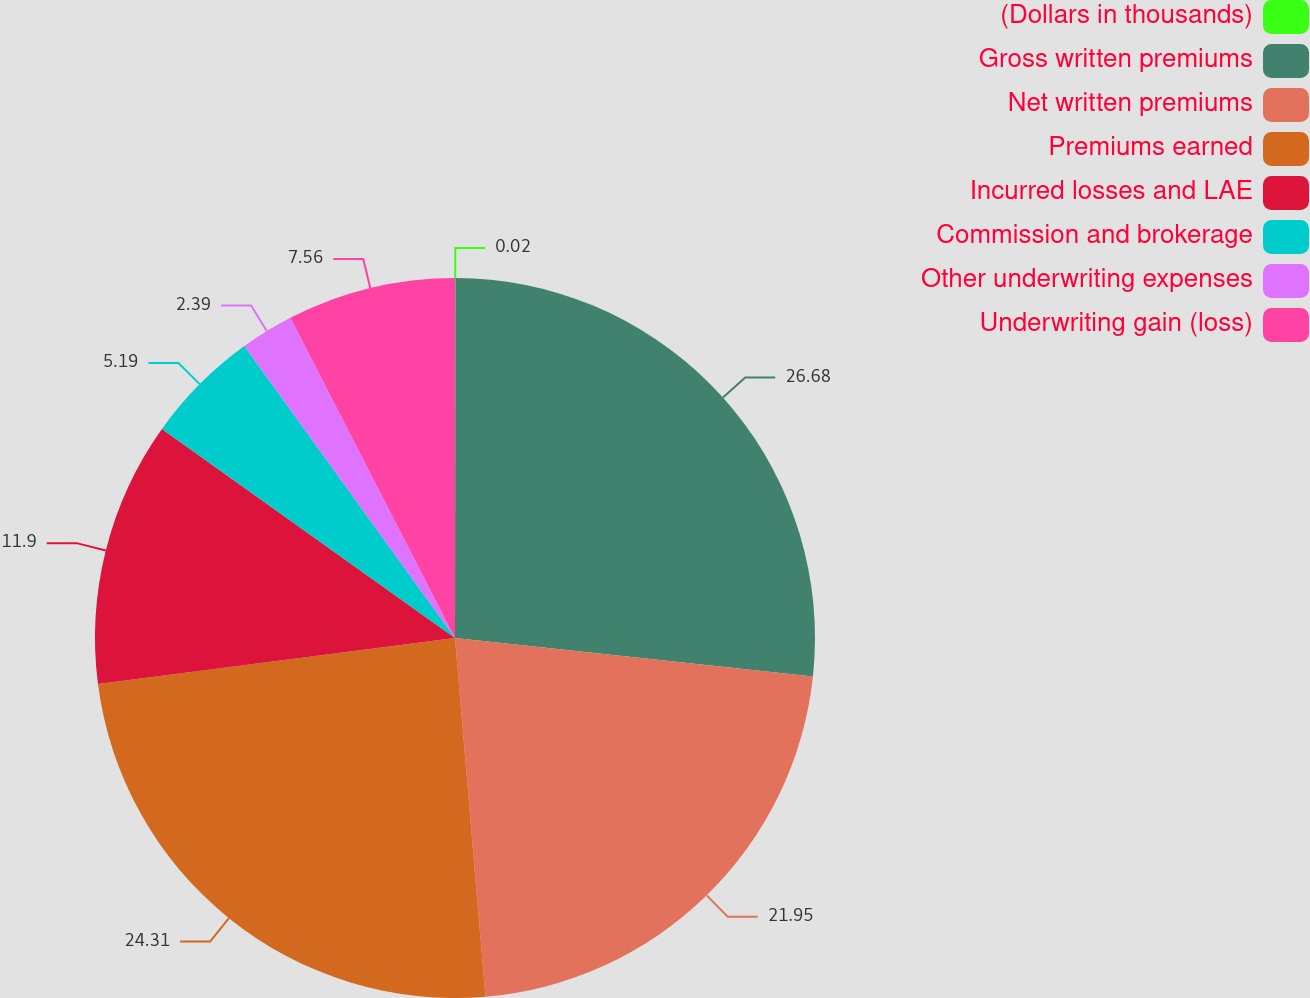Convert chart. <chart><loc_0><loc_0><loc_500><loc_500><pie_chart><fcel>(Dollars in thousands)<fcel>Gross written premiums<fcel>Net written premiums<fcel>Premiums earned<fcel>Incurred losses and LAE<fcel>Commission and brokerage<fcel>Other underwriting expenses<fcel>Underwriting gain (loss)<nl><fcel>0.02%<fcel>26.68%<fcel>21.95%<fcel>24.31%<fcel>11.9%<fcel>5.19%<fcel>2.39%<fcel>7.56%<nl></chart> 